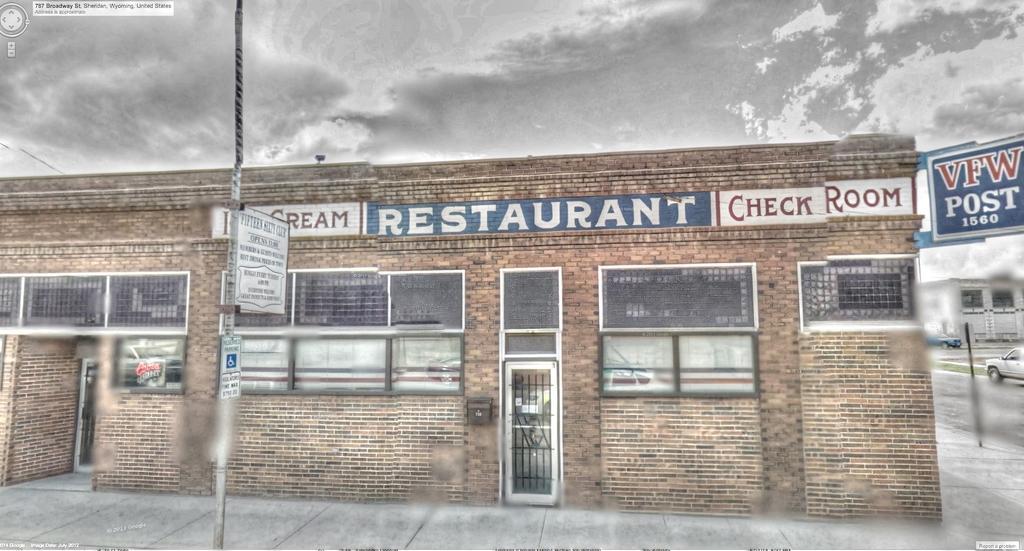Please provide a concise description of this image. In this picture we can see an old restaurant and the building is made of bricks. On the left side of the picture we can see a car moving on the road and on the top of the building we have the sky which is very gloomy. 